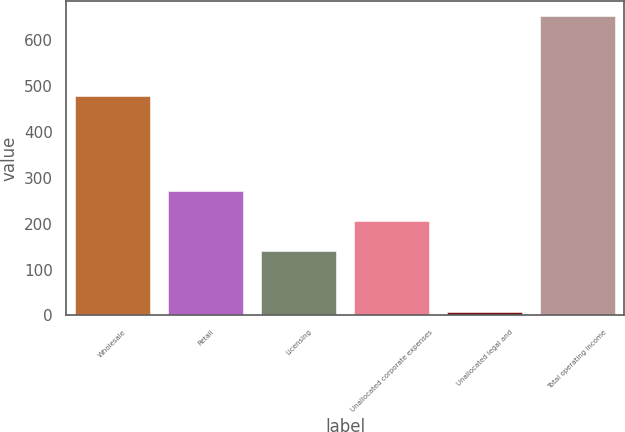Convert chart. <chart><loc_0><loc_0><loc_500><loc_500><bar_chart><fcel>Wholesale<fcel>Retail<fcel>Licensing<fcel>Unallocated corporate expenses<fcel>Unallocated legal and<fcel>Total operating income<nl><fcel>477.8<fcel>270.6<fcel>141.6<fcel>206.1<fcel>7.6<fcel>652.6<nl></chart> 